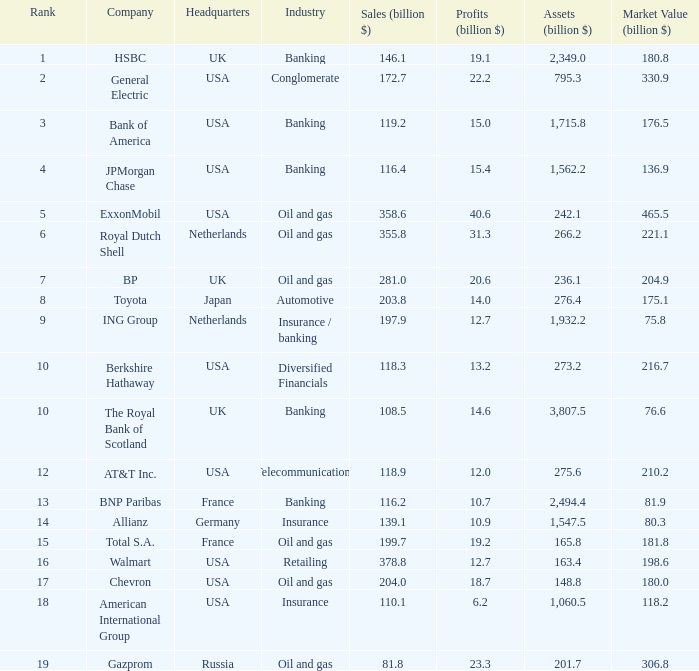Which business field includes a company valued at 80.3 billion in market capitalization? Insurance. 